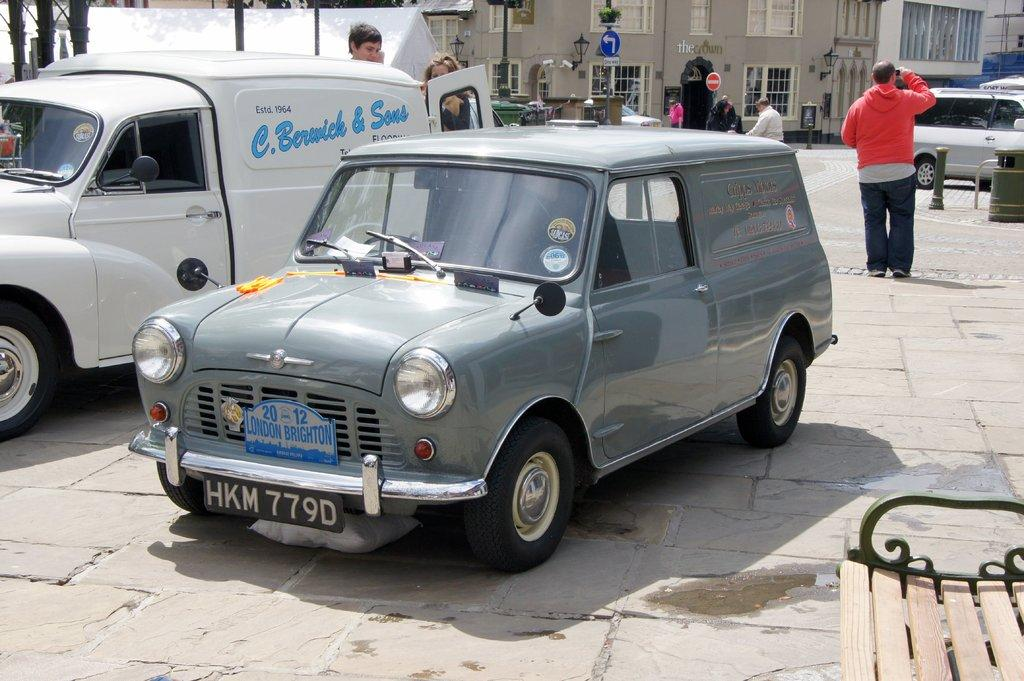What types of vehicles can be seen on the road in the image? There are cars and trucks on the road in the image. What else is happening in the background of the image? There are people walking in the background of the image. What can be seen in the distance in the image? There are buildings in the background of the image. How many babies are sitting on the cart in the image? There is no cart or babies present in the image. 